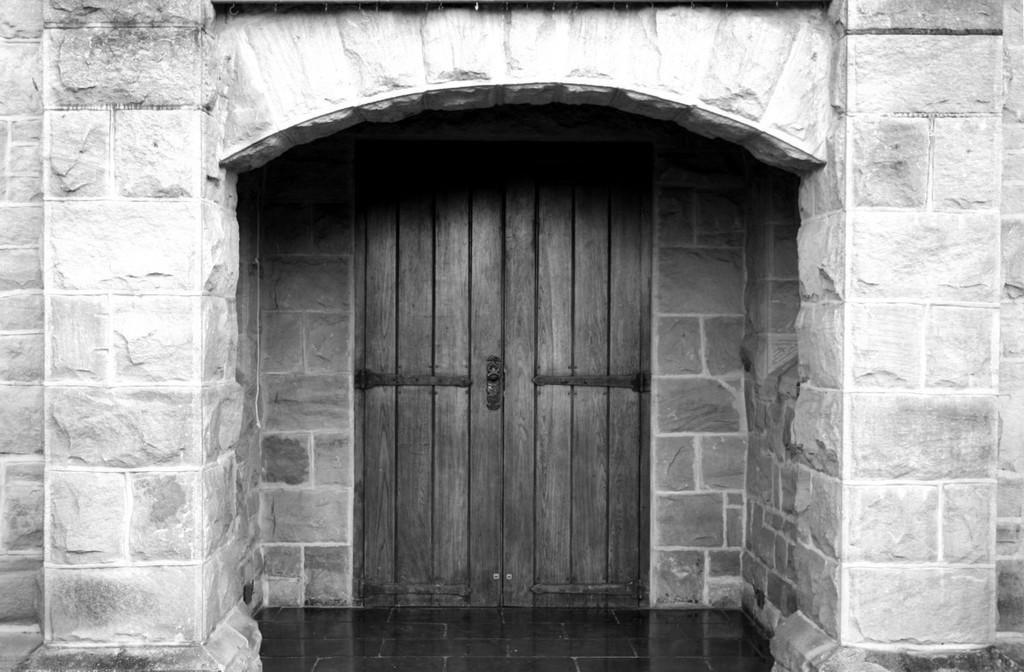Please provide a concise description of this image. In the foreground of this black and white image, there is an arch to the wall. In the background, there is a wooden door. 